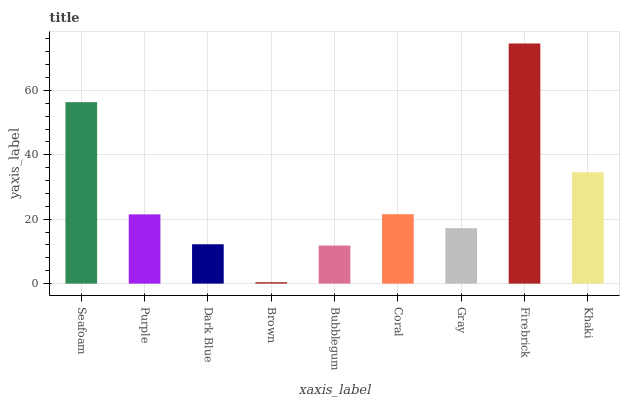Is Brown the minimum?
Answer yes or no. Yes. Is Firebrick the maximum?
Answer yes or no. Yes. Is Purple the minimum?
Answer yes or no. No. Is Purple the maximum?
Answer yes or no. No. Is Seafoam greater than Purple?
Answer yes or no. Yes. Is Purple less than Seafoam?
Answer yes or no. Yes. Is Purple greater than Seafoam?
Answer yes or no. No. Is Seafoam less than Purple?
Answer yes or no. No. Is Purple the high median?
Answer yes or no. Yes. Is Purple the low median?
Answer yes or no. Yes. Is Bubblegum the high median?
Answer yes or no. No. Is Bubblegum the low median?
Answer yes or no. No. 